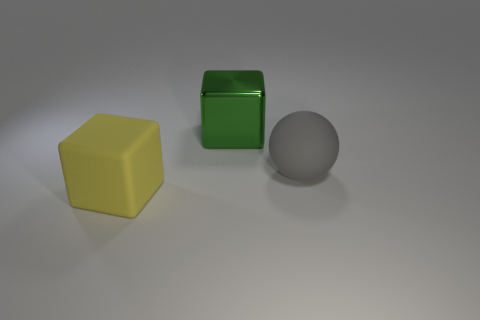What material is the cube behind the matte object behind the thing that is in front of the rubber sphere?
Keep it short and to the point. Metal. The other object that is the same shape as the green metal thing is what size?
Your response must be concise. Large. Is the metal block the same size as the yellow cube?
Offer a very short reply. Yes. Is the number of tiny yellow matte spheres greater than the number of yellow rubber blocks?
Provide a succinct answer. No. What number of things are big objects or yellow cubes?
Offer a very short reply. 3. Is the shape of the object that is in front of the large gray matte object the same as  the large gray matte object?
Your answer should be compact. No. There is a big rubber thing right of the block that is right of the yellow object; what color is it?
Your response must be concise. Gray. Are there fewer red cylinders than big blocks?
Your answer should be very brief. Yes. Are there any large balls that have the same material as the gray thing?
Ensure brevity in your answer.  No. There is a big green object; does it have the same shape as the matte object that is to the left of the big matte ball?
Your answer should be very brief. Yes. 